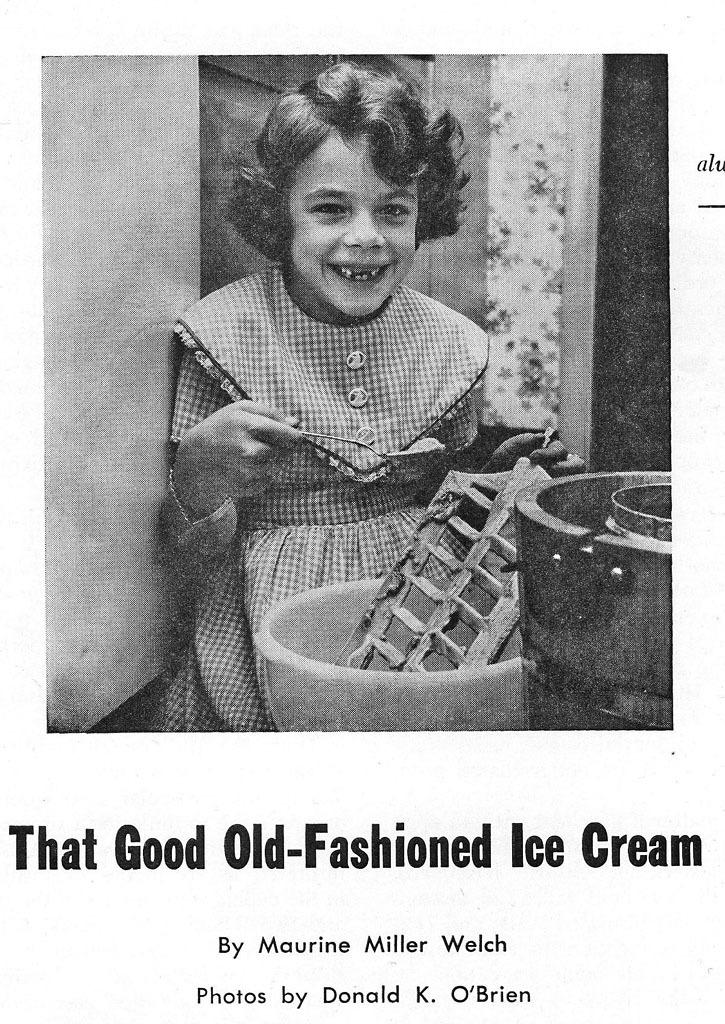What is featured in the image in the center of the poster? The poster contains an image of a child holding an object. Are there any other objects visible on the poster? Yes, there are other objects present on the poster. What can be found on the poster besides images? There are words on the poster. What type of meal is being prepared by the cactus in the image? There is no cactus or meal preparation present in the image; it features a poster with an image of a child holding an object and other objects. 